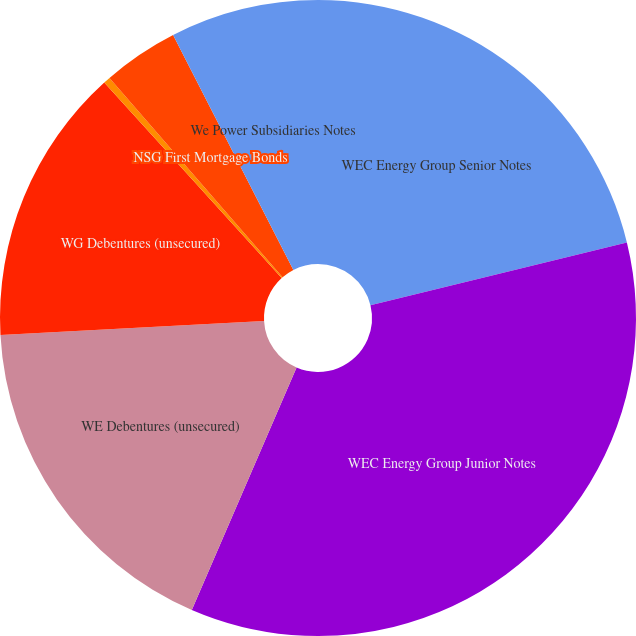Convert chart. <chart><loc_0><loc_0><loc_500><loc_500><pie_chart><fcel>WEC Energy Group Senior Notes<fcel>WEC Energy Group Junior Notes<fcel>WE Debentures (unsecured)<fcel>WG Debentures (unsecured)<fcel>PGL First and Refunding<fcel>NSG First Mortgage Bonds<fcel>We Power Subsidiaries Notes<nl><fcel>21.18%<fcel>35.31%<fcel>17.65%<fcel>14.12%<fcel>0.35%<fcel>3.85%<fcel>7.53%<nl></chart> 